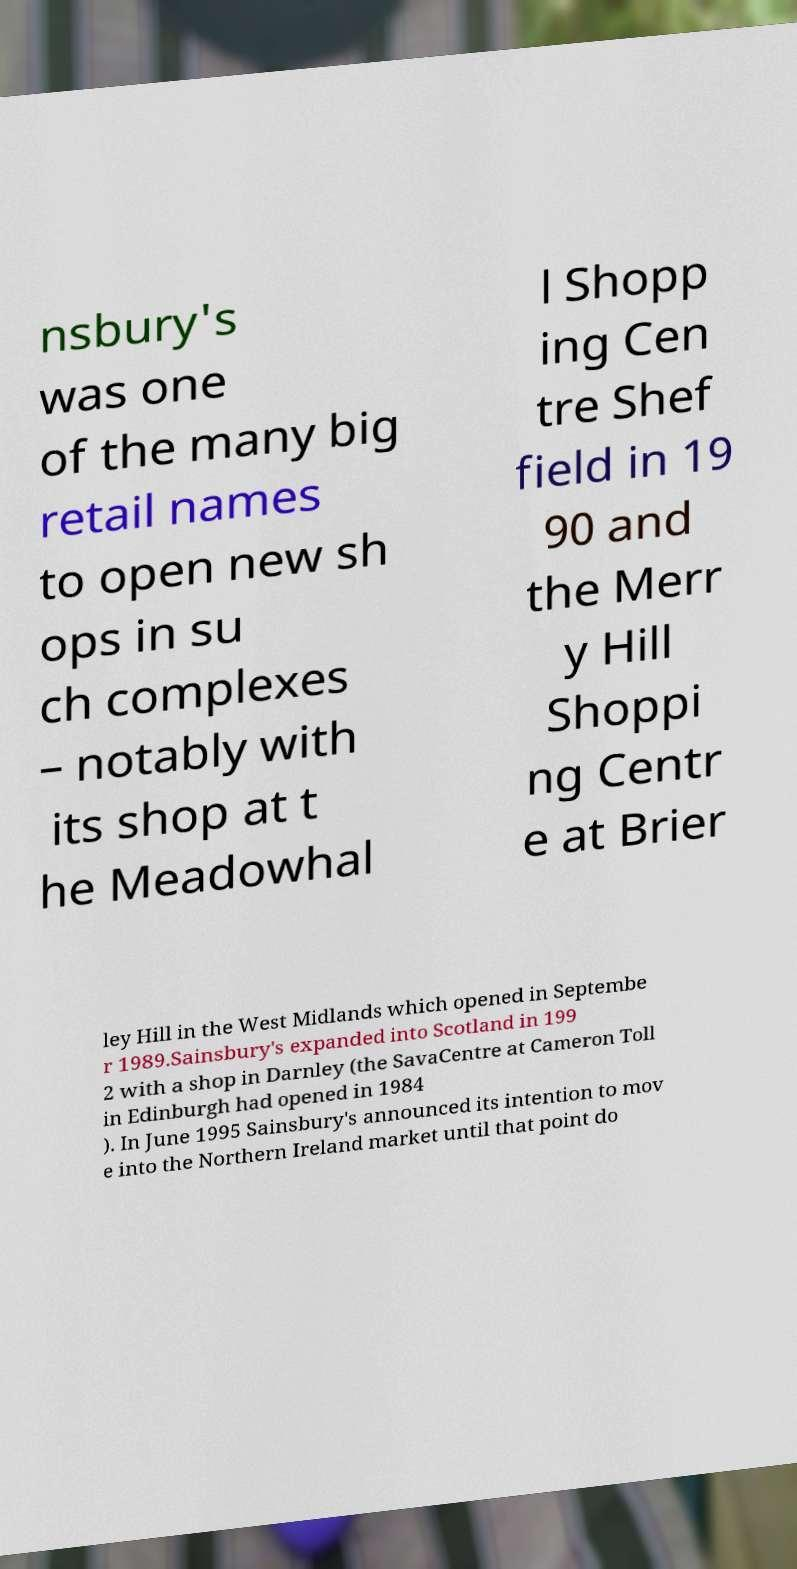Can you accurately transcribe the text from the provided image for me? nsbury's was one of the many big retail names to open new sh ops in su ch complexes – notably with its shop at t he Meadowhal l Shopp ing Cen tre Shef field in 19 90 and the Merr y Hill Shoppi ng Centr e at Brier ley Hill in the West Midlands which opened in Septembe r 1989.Sainsbury's expanded into Scotland in 199 2 with a shop in Darnley (the SavaCentre at Cameron Toll in Edinburgh had opened in 1984 ). In June 1995 Sainsbury's announced its intention to mov e into the Northern Ireland market until that point do 